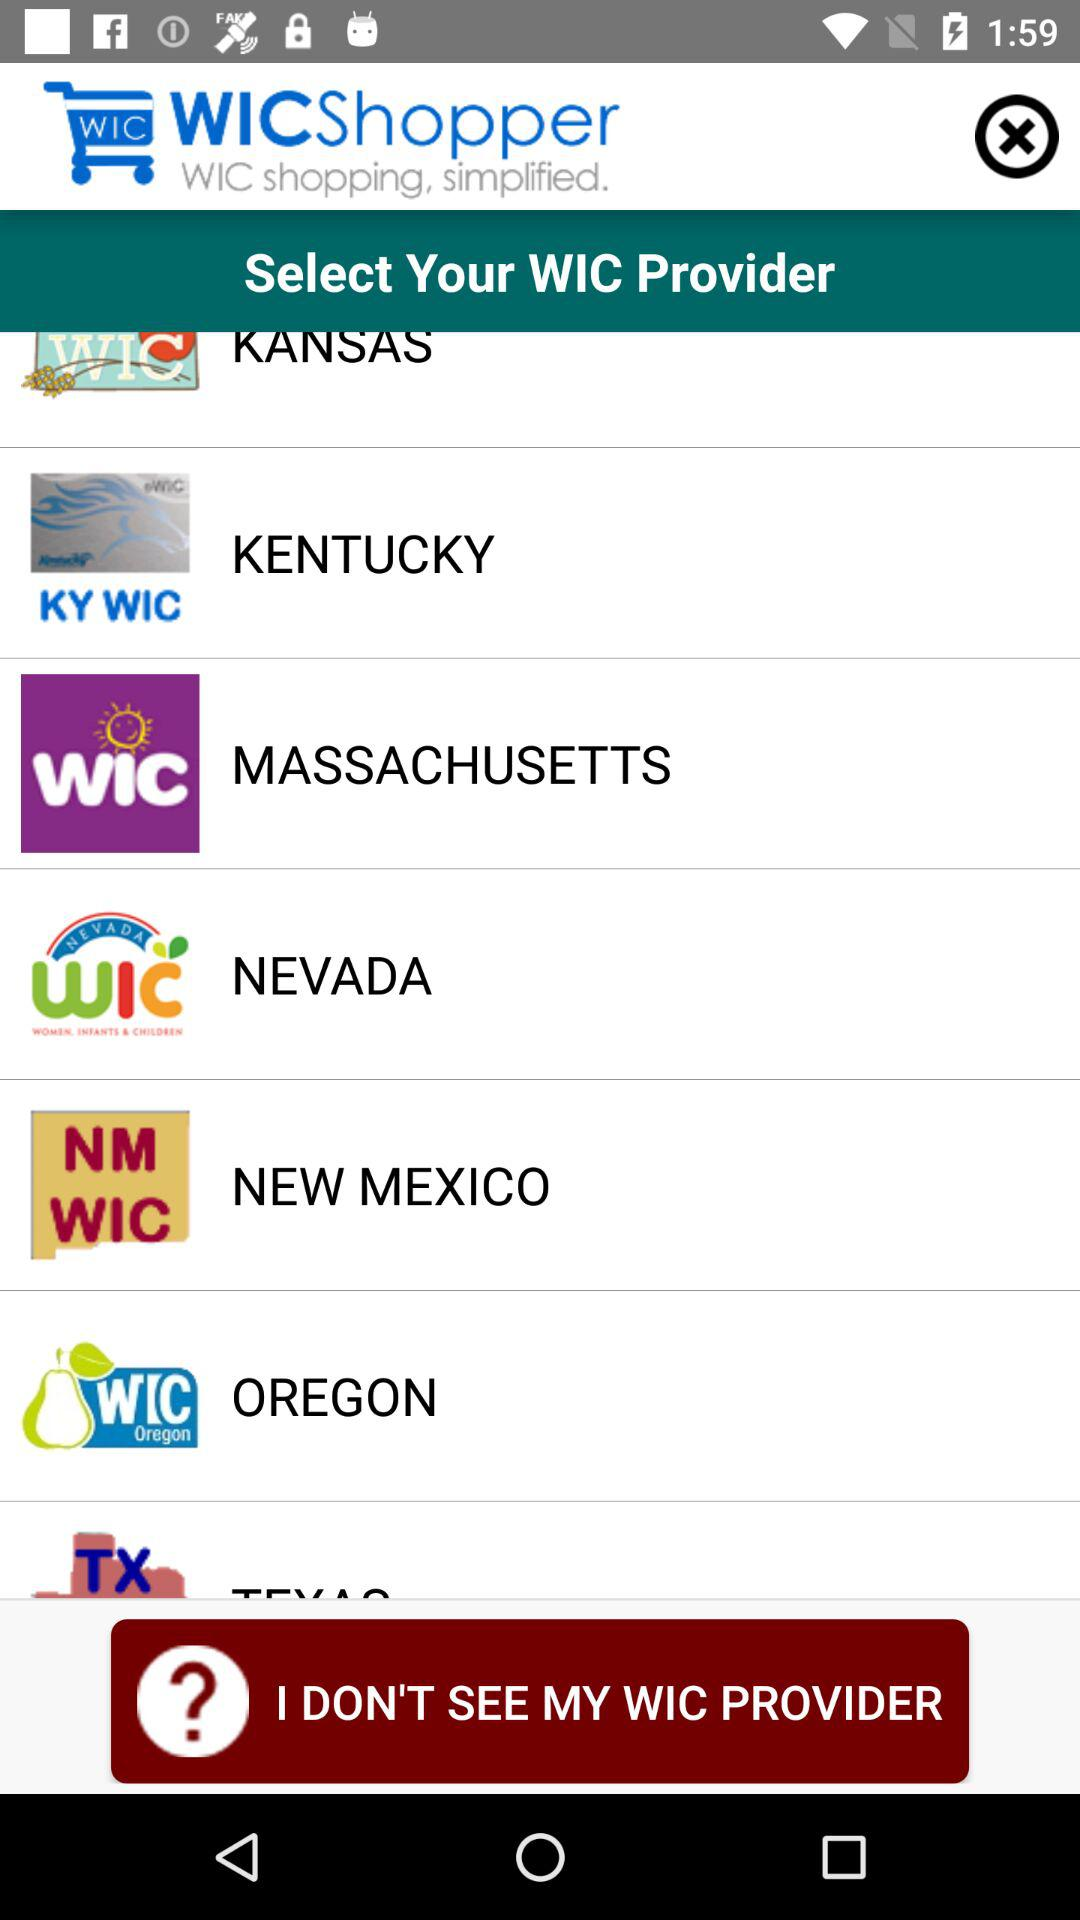How many items are in the cart?
When the provided information is insufficient, respond with <no answer>. <no answer> 